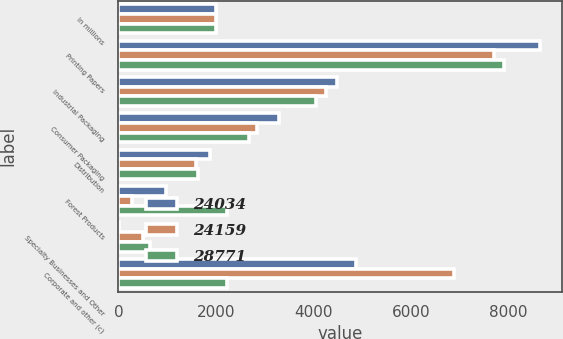Convert chart to OTSL. <chart><loc_0><loc_0><loc_500><loc_500><stacked_bar_chart><ecel><fcel>In millions<fcel>Printing Papers<fcel>Industrial Packaging<fcel>Consumer Packaging<fcel>Distribution<fcel>Forest Products<fcel>Specialty Businesses and Other<fcel>Corporate and other (c)<nl><fcel>24034<fcel>2007<fcel>8650<fcel>4486<fcel>3285<fcel>1875<fcel>984<fcel>12<fcel>4867<nl><fcel>24159<fcel>2006<fcel>7699<fcel>4244<fcel>2840<fcel>1596<fcel>274<fcel>498<fcel>6883<nl><fcel>28771<fcel>2005<fcel>7893<fcel>4042<fcel>2673<fcel>1624<fcel>2234<fcel>652<fcel>2234<nl></chart> 